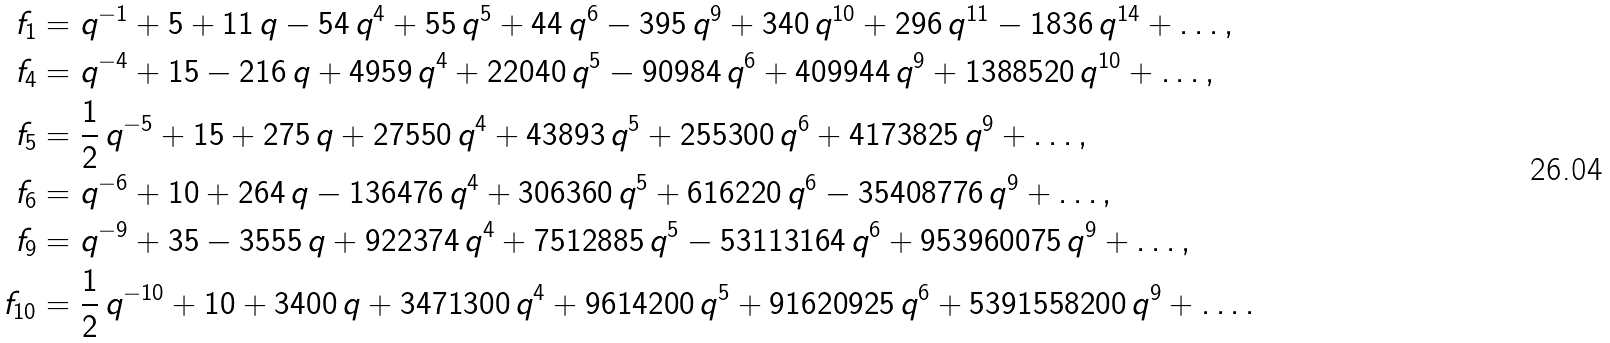Convert formula to latex. <formula><loc_0><loc_0><loc_500><loc_500>f _ { 1 } & = q ^ { - 1 } + 5 + 1 1 \, q - 5 4 \, q ^ { 4 } + 5 5 \, q ^ { 5 } + 4 4 \, q ^ { 6 } - 3 9 5 \, q ^ { 9 } + 3 4 0 \, q ^ { 1 0 } + 2 9 6 \, q ^ { 1 1 } - 1 8 3 6 \, q ^ { 1 4 } + \dots , \\ f _ { 4 } & = q ^ { - 4 } + 1 5 - 2 1 6 \, q + 4 9 5 9 \, q ^ { 4 } + 2 2 0 4 0 \, q ^ { 5 } - 9 0 9 8 4 \, q ^ { 6 } + 4 0 9 9 4 4 \, q ^ { 9 } + 1 3 8 8 5 2 0 \, q ^ { 1 0 } + \dots , \\ f _ { 5 } & = \frac { 1 } { 2 } \, q ^ { - 5 } + 1 5 + 2 7 5 \, q + 2 7 5 5 0 \, q ^ { 4 } + 4 3 8 9 3 \, q ^ { 5 } + 2 5 5 3 0 0 \, q ^ { 6 } + 4 1 7 3 8 2 5 \, q ^ { 9 } + \dots , \\ f _ { 6 } & = q ^ { - 6 } + 1 0 + 2 6 4 \, q - 1 3 6 4 7 6 \, q ^ { 4 } + 3 0 6 3 6 0 \, q ^ { 5 } + 6 1 6 2 2 0 \, q ^ { 6 } - 3 5 4 0 8 7 7 6 \, q ^ { 9 } + \dots , \\ f _ { 9 } & = q ^ { - 9 } + 3 5 - 3 5 5 5 \, q + 9 2 2 3 7 4 \, q ^ { 4 } + 7 5 1 2 8 8 5 \, q ^ { 5 } - 5 3 1 1 3 1 6 4 \, q ^ { 6 } + 9 5 3 9 6 0 0 7 5 \, q ^ { 9 } + \dots , \\ f _ { 1 0 } & = \frac { 1 } { 2 } \, q ^ { - 1 0 } + 1 0 + 3 4 0 0 \, q + 3 4 7 1 3 0 0 \, q ^ { 4 } + 9 6 1 4 2 0 0 \, q ^ { 5 } + 9 1 6 2 0 9 2 5 \, q ^ { 6 } + 5 3 9 1 5 5 8 2 0 0 \, q ^ { 9 } + \dots .</formula> 